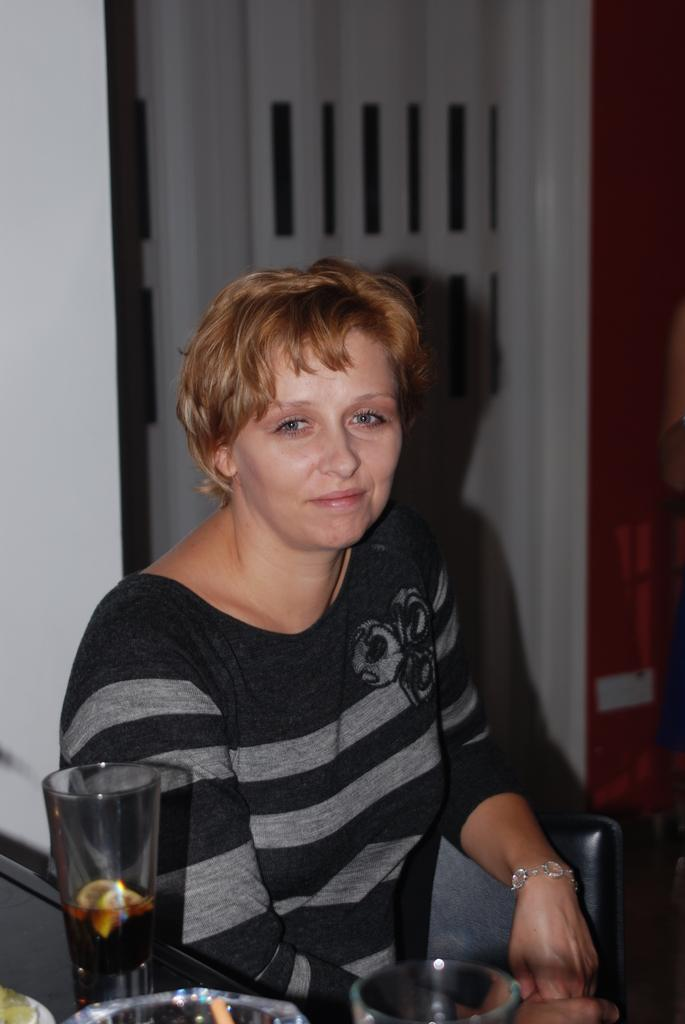What is the person in the image doing? There is a person sitting in the image. What color shirt is the person wearing? The person is wearing a black and gray color shirt. What accessory can be seen in the image? There are glasses visible in the image. What is the color of the wall in the background? There is a white wall in the background of the image. Is the person's mother sitting next to them in the image? There is no information about the person's mother in the image, so we cannot determine if she is present or not. What type of snake is crawling on the table in the image? There is no table or snake present in the image. 